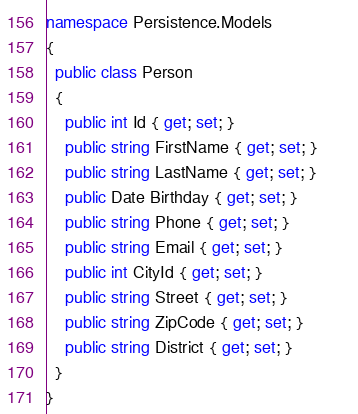Convert code to text. <code><loc_0><loc_0><loc_500><loc_500><_C#_>namespace Persistence.Models{  public class Person  {            public int Id { get; set; }           public string FirstName { get; set; }           public string LastName { get; set; }           public Date Birthday { get; set; }           public string Phone { get; set; }           public string Email { get; set; }           public int CityId { get; set; }           public string Street { get; set; }           public string ZipCode { get; set; }           public string District { get; set; }  }    }</code> 